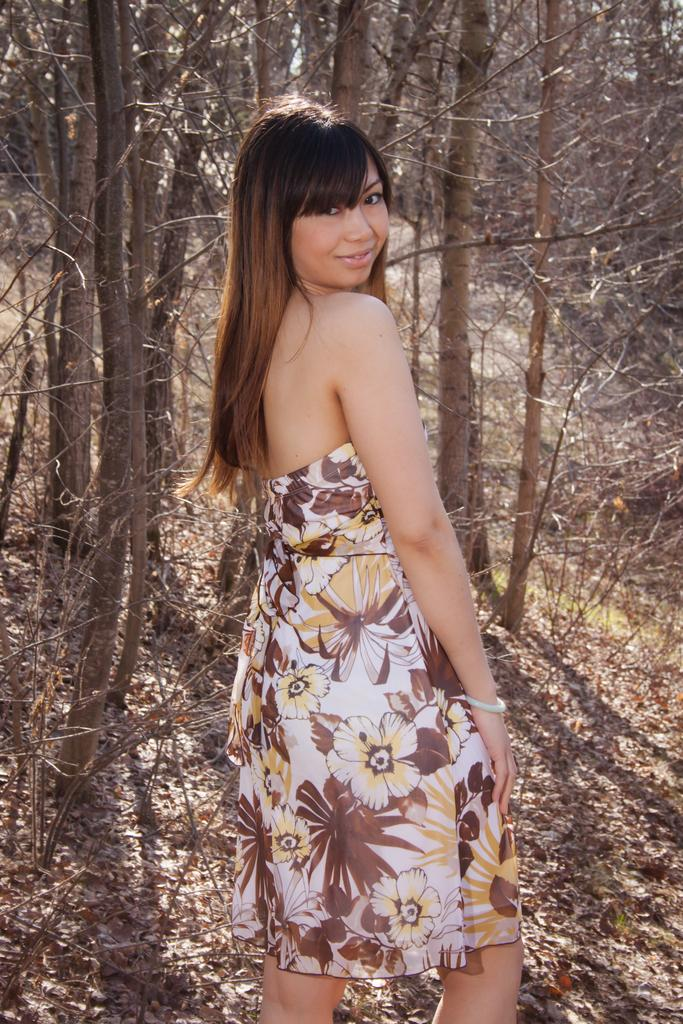Who is present in the image? There is a woman in the image. What is the woman doing in the image? The woman is standing and smiling. What can be seen in the background of the image? There are trees in the background of the image. What is visible at the bottom of the image? Leaves are visible at the bottom of the image. What type of eggnog is being served in the image? There is no eggnog present in the image. How many babies are visible in the image? There are no babies visible in the image. 